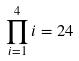Convert formula to latex. <formula><loc_0><loc_0><loc_500><loc_500>\prod _ { i = 1 } ^ { 4 } i = 2 4</formula> 